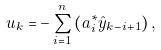Convert formula to latex. <formula><loc_0><loc_0><loc_500><loc_500>u _ { k } = & - \sum _ { i = 1 } ^ { n } \left ( a _ { i } ^ { * } \hat { y } _ { k - i + 1 } \right ) ,</formula> 